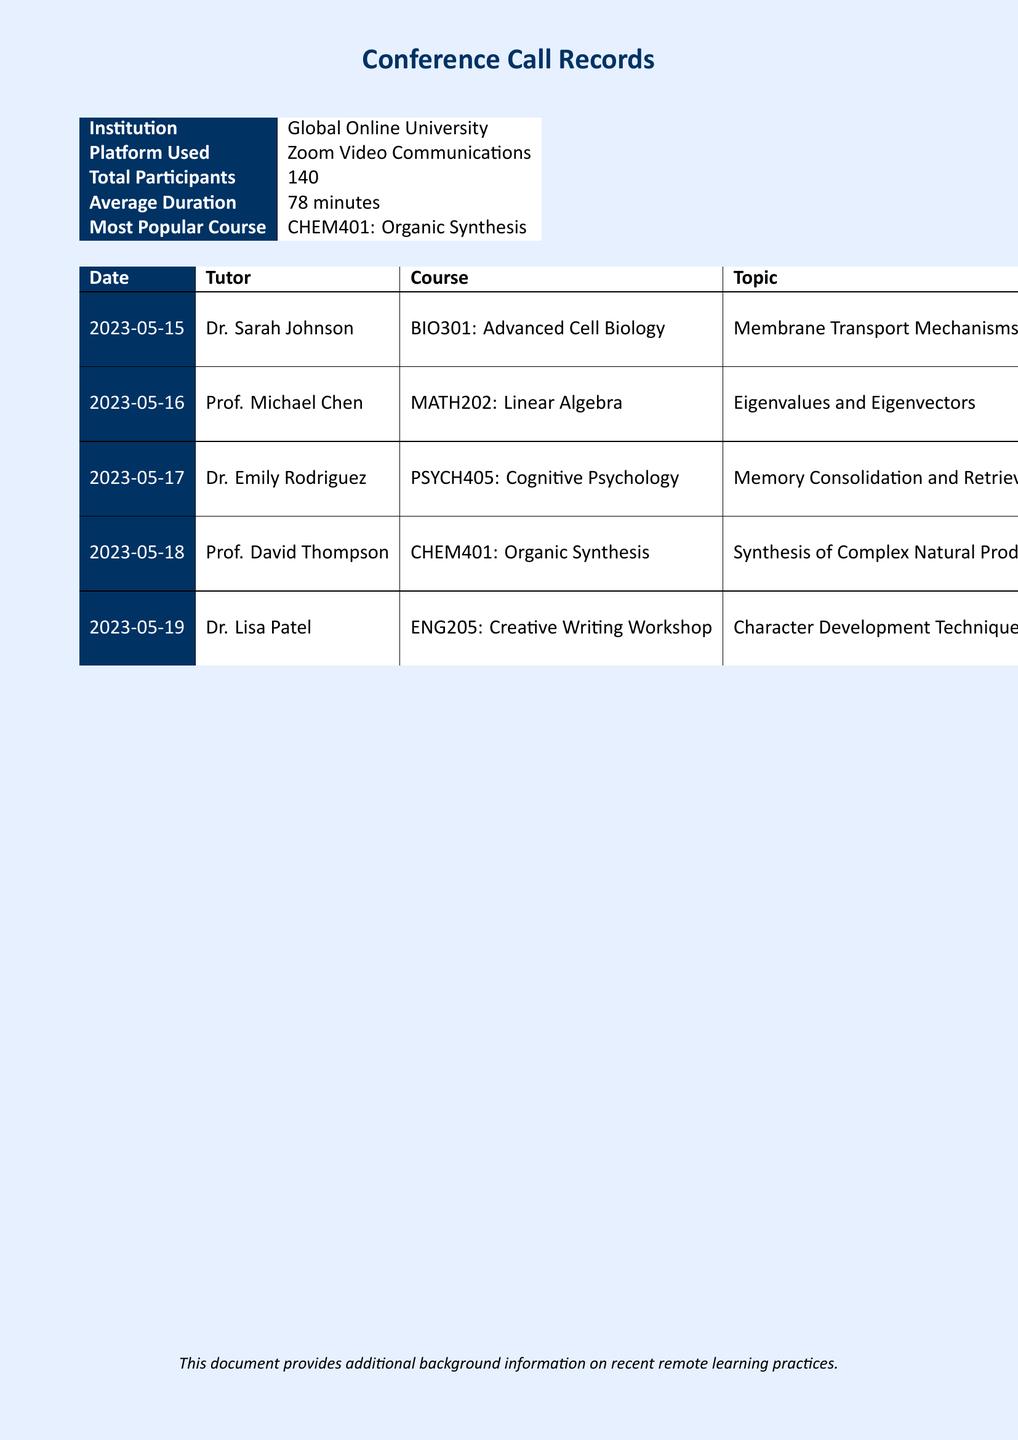What is the average duration of the calls? The average duration provided in the document is the mean of all call durations listed, which is 78 minutes.
Answer: 78 minutes Who conducted the session on May 18, 2023? The document specifies that Prof. David Thompson conducted the session on this date.
Answer: Prof. David Thompson How many participants attended the CHEM401 session? The specific session on CHEM401 on May 18 included 40 participants, as stated in the document.
Answer: 40 What was the topic of the session led by Dr. Emily Rodriguez? The document details that the topic covered by Dr. Emily Rodriguez was Memory Consolidation and Retrieval.
Answer: Memory Consolidation and Retrieval Which course had the highest participant count? By reviewing participant counts across all sessions, it is clear that MATH202 had the highest attendance of 35 participants.
Answer: MATH202: Linear Algebra What is the total number of conference calls recorded in the document? The document lists five specific conference call sessions conducted by various tutors.
Answer: 5 Which tutor had the shortest session duration? The document identifies Dr. Lisa Patel's session, which lasted 45 minutes, as the shortest.
Answer: Dr. Lisa Patel What was the most popular course mentioned in the records? The document states that CHEM401: Organic Synthesis is the most popular course based on participation.
Answer: CHEM401: Organic Synthesis What date did the session on Membrane Transport Mechanisms occur? The document records that the session took place on May 15, 2023.
Answer: May 15, 2023 